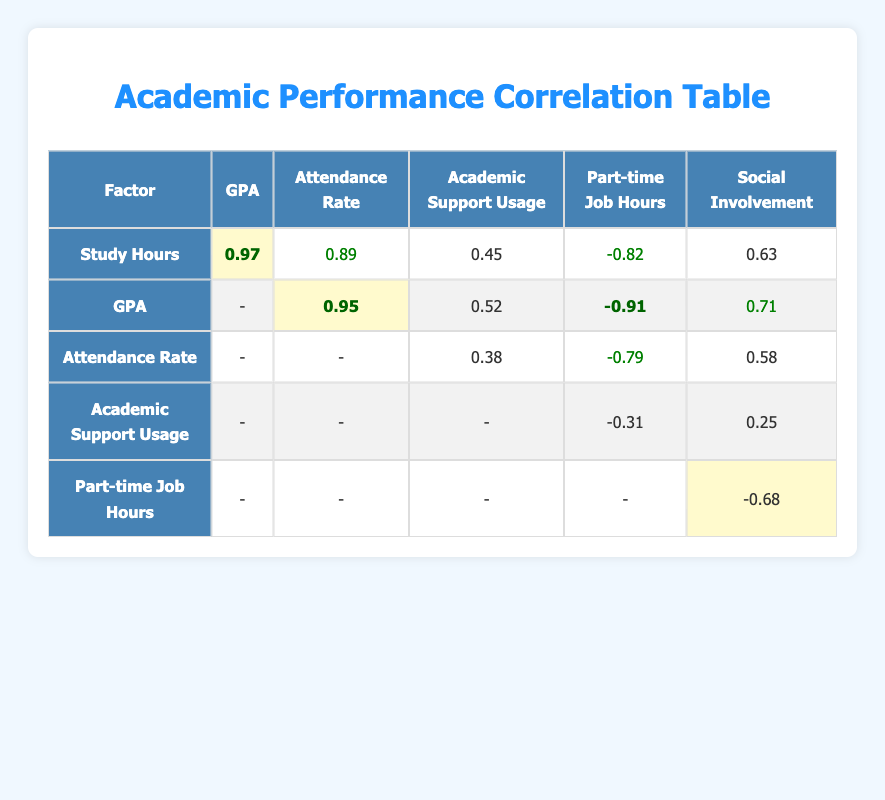What is the correlation between study hours and GPA? The table shows a correlation of 0.97 between study hours and GPA, indicating a very strong positive correlation. This suggests that as study hours increase, GPA tends to increase as well.
Answer: 0.97 Is there a positive correlation between attendance rate and GPA? Yes, the correlation value between attendance rate and GPA is 0.95, which means there is a very strong positive relationship; higher attendance rates are associated with higher GPAs.
Answer: Yes What is the correlation between academic support usage and social involvement score? The correlation value for academic support usage and social involvement score is 0.25. This indicates a weak positive correlation; there is a slight tendency for more academic support usage to be linked with higher social involvement scores.
Answer: 0.25 What is the difference in correlation between part-time job hours and GPA compared to study hours and GPA? The correlation between part-time job hours and GPA is -0.91, while the correlation between study hours and GPA is 0.97. The difference is calculated as 0.97 - (-0.91) = 1.88, showcasing a significant contrast where one is positive and the other is negative.
Answer: 1.88 Is the correlation between attendance rate and part-time job hours negative? Yes, the correlation between attendance rate and part-time job hours is -0.79, indicating that as the part-time job hours increase, the attendance rate tends to decrease.
Answer: Yes What is the average correlation coefficient for academic support usage across all factors? The correlation coefficients for academic support usage with the other factors are: 0.45 (with study hours), 0.52 (with GPA), 0.38 (with attendance rate), and 0.25 (with social involvement). Summing these gives 0.45 + 0.52 + 0.38 + 0.25 = 1.60, and dividing by 4 (the number of correlations) gives an average of 0.40.
Answer: 0.40 Is the correlation between study hours and attendance rate higher than 0.80? Yes, the correlation between study hours and attendance rate is 0.89, which is indeed higher than 0.80, signifying a strong positive relationship.
Answer: Yes What is the correlation between attendance rate and social involvement score? The correlation value between attendance rate and social involvement score is 0.58, indicating a moderate positive correlation, which suggests that higher attendance rates are often associated with higher social involvement scores.
Answer: 0.58 What is the highest negative correlation in the table? The highest negative correlation in the table is between part-time job hours and GPA, which is -0.91, indicating that higher work hours are strongly correlated with lower GPAs.
Answer: -0.91 